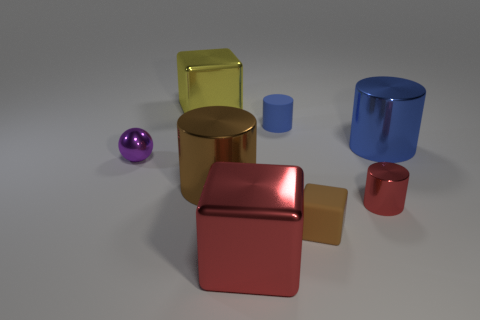Subtract all brown cylinders. How many cylinders are left? 3 Subtract all tiny matte cylinders. How many cylinders are left? 3 Subtract 2 cylinders. How many cylinders are left? 2 Add 2 yellow shiny objects. How many objects exist? 10 Subtract all yellow cylinders. Subtract all yellow spheres. How many cylinders are left? 4 Subtract all spheres. How many objects are left? 7 Add 4 big blue objects. How many big blue objects are left? 5 Add 7 tiny balls. How many tiny balls exist? 8 Subtract 1 brown cylinders. How many objects are left? 7 Subtract all purple metallic cubes. Subtract all blue cylinders. How many objects are left? 6 